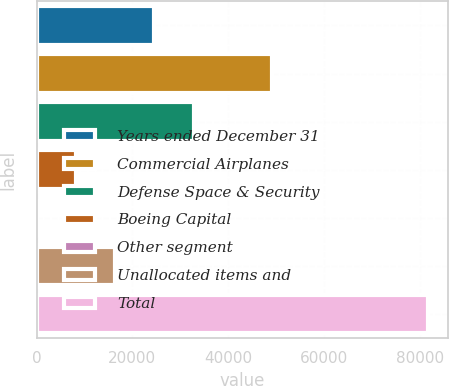<chart> <loc_0><loc_0><loc_500><loc_500><bar_chart><fcel>Years ended December 31<fcel>Commercial Airplanes<fcel>Defense Space & Security<fcel>Boeing Capital<fcel>Other segment<fcel>Unallocated items and<fcel>Total<nl><fcel>24602.5<fcel>49127<fcel>32759<fcel>8289.5<fcel>133<fcel>16446<fcel>81698<nl></chart> 